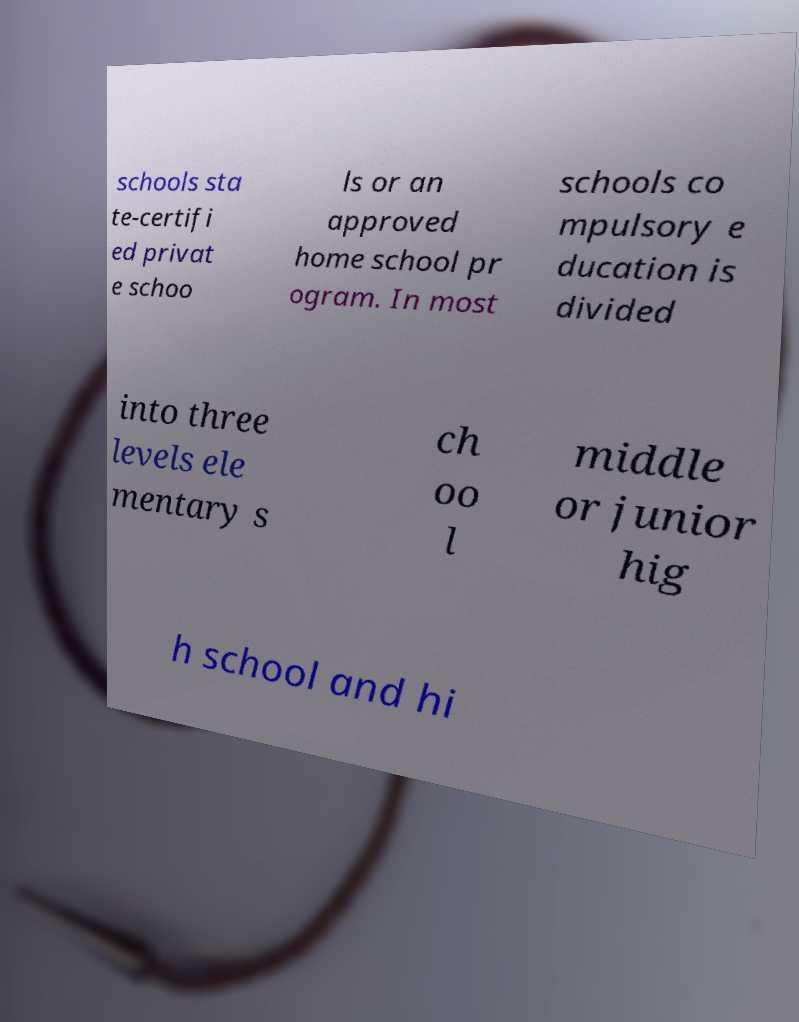Please identify and transcribe the text found in this image. schools sta te-certifi ed privat e schoo ls or an approved home school pr ogram. In most schools co mpulsory e ducation is divided into three levels ele mentary s ch oo l middle or junior hig h school and hi 